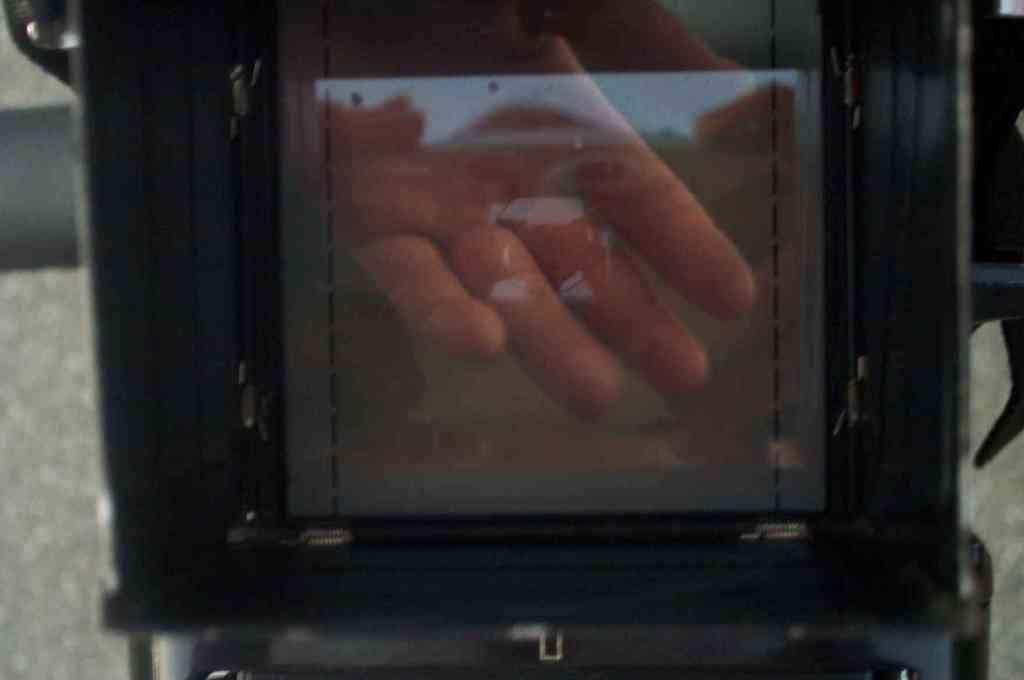What is the main subject in the front of the image? There is an object in the front of the image. What can be said about the color of the object? The object is black in color. Can you describe any human interaction with the object? The hand of a person is visible on the object. How does the object contribute to the process of digestion in the image? The image does not show any digestion process, and the object's purpose is not related to digestion. 